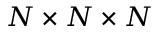Convert formula to latex. <formula><loc_0><loc_0><loc_500><loc_500>N \times N \times N</formula> 